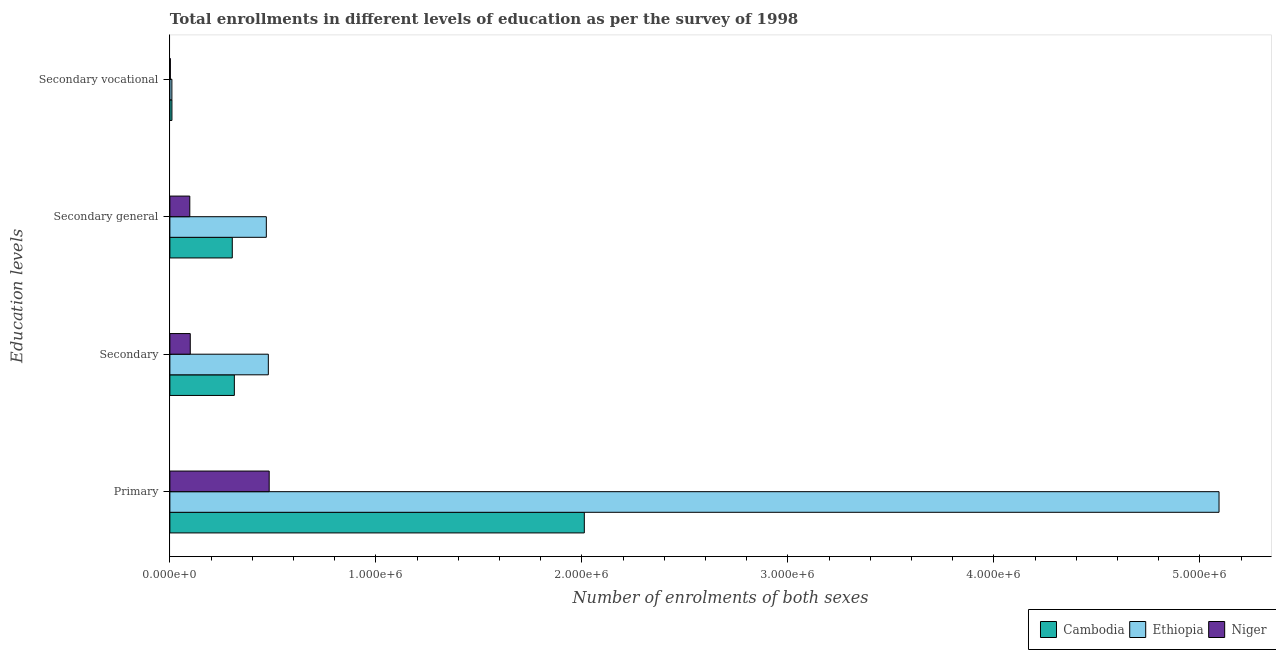How many different coloured bars are there?
Your answer should be very brief. 3. How many bars are there on the 3rd tick from the bottom?
Keep it short and to the point. 3. What is the label of the 4th group of bars from the top?
Your answer should be compact. Primary. What is the number of enrolments in secondary education in Cambodia?
Give a very brief answer. 3.13e+05. Across all countries, what is the maximum number of enrolments in primary education?
Offer a very short reply. 5.09e+06. Across all countries, what is the minimum number of enrolments in secondary general education?
Ensure brevity in your answer.  9.67e+04. In which country was the number of enrolments in secondary general education maximum?
Your answer should be very brief. Ethiopia. In which country was the number of enrolments in secondary general education minimum?
Give a very brief answer. Niger. What is the total number of enrolments in secondary education in the graph?
Your answer should be compact. 8.90e+05. What is the difference between the number of enrolments in secondary general education in Niger and that in Cambodia?
Offer a very short reply. -2.06e+05. What is the difference between the number of enrolments in secondary vocational education in Niger and the number of enrolments in primary education in Cambodia?
Your answer should be very brief. -2.01e+06. What is the average number of enrolments in secondary education per country?
Ensure brevity in your answer.  2.97e+05. What is the difference between the number of enrolments in secondary general education and number of enrolments in secondary vocational education in Cambodia?
Offer a very short reply. 2.93e+05. What is the ratio of the number of enrolments in secondary vocational education in Ethiopia to that in Niger?
Provide a succinct answer. 4.33. Is the number of enrolments in primary education in Cambodia less than that in Niger?
Give a very brief answer. No. What is the difference between the highest and the second highest number of enrolments in secondary education?
Provide a short and direct response. 1.65e+05. What is the difference between the highest and the lowest number of enrolments in secondary vocational education?
Provide a short and direct response. 7729. What does the 1st bar from the top in Secondary vocational represents?
Your answer should be compact. Niger. What does the 3rd bar from the bottom in Secondary represents?
Provide a succinct answer. Niger. Is it the case that in every country, the sum of the number of enrolments in primary education and number of enrolments in secondary education is greater than the number of enrolments in secondary general education?
Provide a short and direct response. Yes. How many bars are there?
Keep it short and to the point. 12. Are all the bars in the graph horizontal?
Provide a short and direct response. Yes. Does the graph contain any zero values?
Offer a terse response. No. Does the graph contain grids?
Keep it short and to the point. No. Where does the legend appear in the graph?
Your answer should be compact. Bottom right. What is the title of the graph?
Provide a short and direct response. Total enrollments in different levels of education as per the survey of 1998. What is the label or title of the X-axis?
Keep it short and to the point. Number of enrolments of both sexes. What is the label or title of the Y-axis?
Provide a short and direct response. Education levels. What is the Number of enrolments of both sexes in Cambodia in Primary?
Offer a very short reply. 2.01e+06. What is the Number of enrolments of both sexes of Ethiopia in Primary?
Offer a very short reply. 5.09e+06. What is the Number of enrolments of both sexes of Niger in Primary?
Ensure brevity in your answer.  4.82e+05. What is the Number of enrolments of both sexes of Cambodia in Secondary?
Make the answer very short. 3.13e+05. What is the Number of enrolments of both sexes of Ethiopia in Secondary?
Your answer should be very brief. 4.78e+05. What is the Number of enrolments of both sexes in Niger in Secondary?
Give a very brief answer. 9.90e+04. What is the Number of enrolments of both sexes of Cambodia in Secondary general?
Keep it short and to the point. 3.03e+05. What is the Number of enrolments of both sexes in Ethiopia in Secondary general?
Provide a succinct answer. 4.68e+05. What is the Number of enrolments of both sexes of Niger in Secondary general?
Your answer should be very brief. 9.67e+04. What is the Number of enrolments of both sexes of Cambodia in Secondary vocational?
Provide a succinct answer. 9983. What is the Number of enrolments of both sexes of Ethiopia in Secondary vocational?
Your answer should be compact. 9771. What is the Number of enrolments of both sexes in Niger in Secondary vocational?
Offer a very short reply. 2254. Across all Education levels, what is the maximum Number of enrolments of both sexes in Cambodia?
Offer a terse response. 2.01e+06. Across all Education levels, what is the maximum Number of enrolments of both sexes in Ethiopia?
Keep it short and to the point. 5.09e+06. Across all Education levels, what is the maximum Number of enrolments of both sexes of Niger?
Provide a short and direct response. 4.82e+05. Across all Education levels, what is the minimum Number of enrolments of both sexes in Cambodia?
Provide a short and direct response. 9983. Across all Education levels, what is the minimum Number of enrolments of both sexes in Ethiopia?
Keep it short and to the point. 9771. Across all Education levels, what is the minimum Number of enrolments of both sexes in Niger?
Your answer should be very brief. 2254. What is the total Number of enrolments of both sexes in Cambodia in the graph?
Give a very brief answer. 2.64e+06. What is the total Number of enrolments of both sexes in Ethiopia in the graph?
Provide a short and direct response. 6.05e+06. What is the total Number of enrolments of both sexes of Niger in the graph?
Make the answer very short. 6.80e+05. What is the difference between the Number of enrolments of both sexes in Cambodia in Primary and that in Secondary?
Keep it short and to the point. 1.70e+06. What is the difference between the Number of enrolments of both sexes of Ethiopia in Primary and that in Secondary?
Provide a succinct answer. 4.61e+06. What is the difference between the Number of enrolments of both sexes in Niger in Primary and that in Secondary?
Offer a very short reply. 3.83e+05. What is the difference between the Number of enrolments of both sexes of Cambodia in Primary and that in Secondary general?
Your response must be concise. 1.71e+06. What is the difference between the Number of enrolments of both sexes in Ethiopia in Primary and that in Secondary general?
Your response must be concise. 4.62e+06. What is the difference between the Number of enrolments of both sexes in Niger in Primary and that in Secondary general?
Your answer should be compact. 3.85e+05. What is the difference between the Number of enrolments of both sexes in Cambodia in Primary and that in Secondary vocational?
Your response must be concise. 2.00e+06. What is the difference between the Number of enrolments of both sexes in Ethiopia in Primary and that in Secondary vocational?
Your answer should be very brief. 5.08e+06. What is the difference between the Number of enrolments of both sexes in Niger in Primary and that in Secondary vocational?
Keep it short and to the point. 4.80e+05. What is the difference between the Number of enrolments of both sexes of Cambodia in Secondary and that in Secondary general?
Give a very brief answer. 9983. What is the difference between the Number of enrolments of both sexes of Ethiopia in Secondary and that in Secondary general?
Ensure brevity in your answer.  9771. What is the difference between the Number of enrolments of both sexes of Niger in Secondary and that in Secondary general?
Offer a terse response. 2254. What is the difference between the Number of enrolments of both sexes in Cambodia in Secondary and that in Secondary vocational?
Keep it short and to the point. 3.03e+05. What is the difference between the Number of enrolments of both sexes in Ethiopia in Secondary and that in Secondary vocational?
Offer a terse response. 4.68e+05. What is the difference between the Number of enrolments of both sexes of Niger in Secondary and that in Secondary vocational?
Make the answer very short. 9.67e+04. What is the difference between the Number of enrolments of both sexes in Cambodia in Secondary general and that in Secondary vocational?
Your response must be concise. 2.93e+05. What is the difference between the Number of enrolments of both sexes of Ethiopia in Secondary general and that in Secondary vocational?
Keep it short and to the point. 4.58e+05. What is the difference between the Number of enrolments of both sexes in Niger in Secondary general and that in Secondary vocational?
Offer a very short reply. 9.45e+04. What is the difference between the Number of enrolments of both sexes in Cambodia in Primary and the Number of enrolments of both sexes in Ethiopia in Secondary?
Provide a succinct answer. 1.53e+06. What is the difference between the Number of enrolments of both sexes in Cambodia in Primary and the Number of enrolments of both sexes in Niger in Secondary?
Offer a terse response. 1.91e+06. What is the difference between the Number of enrolments of both sexes of Ethiopia in Primary and the Number of enrolments of both sexes of Niger in Secondary?
Offer a terse response. 4.99e+06. What is the difference between the Number of enrolments of both sexes in Cambodia in Primary and the Number of enrolments of both sexes in Ethiopia in Secondary general?
Offer a terse response. 1.54e+06. What is the difference between the Number of enrolments of both sexes of Cambodia in Primary and the Number of enrolments of both sexes of Niger in Secondary general?
Keep it short and to the point. 1.92e+06. What is the difference between the Number of enrolments of both sexes in Ethiopia in Primary and the Number of enrolments of both sexes in Niger in Secondary general?
Provide a short and direct response. 5.00e+06. What is the difference between the Number of enrolments of both sexes of Cambodia in Primary and the Number of enrolments of both sexes of Ethiopia in Secondary vocational?
Your answer should be very brief. 2.00e+06. What is the difference between the Number of enrolments of both sexes in Cambodia in Primary and the Number of enrolments of both sexes in Niger in Secondary vocational?
Your answer should be very brief. 2.01e+06. What is the difference between the Number of enrolments of both sexes of Ethiopia in Primary and the Number of enrolments of both sexes of Niger in Secondary vocational?
Keep it short and to the point. 5.09e+06. What is the difference between the Number of enrolments of both sexes in Cambodia in Secondary and the Number of enrolments of both sexes in Ethiopia in Secondary general?
Offer a very short reply. -1.55e+05. What is the difference between the Number of enrolments of both sexes in Cambodia in Secondary and the Number of enrolments of both sexes in Niger in Secondary general?
Your response must be concise. 2.16e+05. What is the difference between the Number of enrolments of both sexes of Ethiopia in Secondary and the Number of enrolments of both sexes of Niger in Secondary general?
Make the answer very short. 3.81e+05. What is the difference between the Number of enrolments of both sexes of Cambodia in Secondary and the Number of enrolments of both sexes of Ethiopia in Secondary vocational?
Your answer should be very brief. 3.03e+05. What is the difference between the Number of enrolments of both sexes in Cambodia in Secondary and the Number of enrolments of both sexes in Niger in Secondary vocational?
Keep it short and to the point. 3.11e+05. What is the difference between the Number of enrolments of both sexes in Ethiopia in Secondary and the Number of enrolments of both sexes in Niger in Secondary vocational?
Provide a short and direct response. 4.76e+05. What is the difference between the Number of enrolments of both sexes of Cambodia in Secondary general and the Number of enrolments of both sexes of Ethiopia in Secondary vocational?
Provide a short and direct response. 2.93e+05. What is the difference between the Number of enrolments of both sexes in Cambodia in Secondary general and the Number of enrolments of both sexes in Niger in Secondary vocational?
Your answer should be very brief. 3.01e+05. What is the difference between the Number of enrolments of both sexes of Ethiopia in Secondary general and the Number of enrolments of both sexes of Niger in Secondary vocational?
Give a very brief answer. 4.66e+05. What is the average Number of enrolments of both sexes in Cambodia per Education levels?
Your answer should be very brief. 6.59e+05. What is the average Number of enrolments of both sexes in Ethiopia per Education levels?
Give a very brief answer. 1.51e+06. What is the average Number of enrolments of both sexes in Niger per Education levels?
Make the answer very short. 1.70e+05. What is the difference between the Number of enrolments of both sexes of Cambodia and Number of enrolments of both sexes of Ethiopia in Primary?
Your answer should be very brief. -3.08e+06. What is the difference between the Number of enrolments of both sexes in Cambodia and Number of enrolments of both sexes in Niger in Primary?
Provide a succinct answer. 1.53e+06. What is the difference between the Number of enrolments of both sexes in Ethiopia and Number of enrolments of both sexes in Niger in Primary?
Give a very brief answer. 4.61e+06. What is the difference between the Number of enrolments of both sexes of Cambodia and Number of enrolments of both sexes of Ethiopia in Secondary?
Provide a short and direct response. -1.65e+05. What is the difference between the Number of enrolments of both sexes in Cambodia and Number of enrolments of both sexes in Niger in Secondary?
Offer a terse response. 2.14e+05. What is the difference between the Number of enrolments of both sexes of Ethiopia and Number of enrolments of both sexes of Niger in Secondary?
Your answer should be very brief. 3.79e+05. What is the difference between the Number of enrolments of both sexes of Cambodia and Number of enrolments of both sexes of Ethiopia in Secondary general?
Keep it short and to the point. -1.65e+05. What is the difference between the Number of enrolments of both sexes of Cambodia and Number of enrolments of both sexes of Niger in Secondary general?
Make the answer very short. 2.06e+05. What is the difference between the Number of enrolments of both sexes in Ethiopia and Number of enrolments of both sexes in Niger in Secondary general?
Offer a terse response. 3.71e+05. What is the difference between the Number of enrolments of both sexes of Cambodia and Number of enrolments of both sexes of Ethiopia in Secondary vocational?
Provide a short and direct response. 212. What is the difference between the Number of enrolments of both sexes in Cambodia and Number of enrolments of both sexes in Niger in Secondary vocational?
Ensure brevity in your answer.  7729. What is the difference between the Number of enrolments of both sexes in Ethiopia and Number of enrolments of both sexes in Niger in Secondary vocational?
Your answer should be compact. 7517. What is the ratio of the Number of enrolments of both sexes of Cambodia in Primary to that in Secondary?
Make the answer very short. 6.43. What is the ratio of the Number of enrolments of both sexes of Ethiopia in Primary to that in Secondary?
Provide a succinct answer. 10.66. What is the ratio of the Number of enrolments of both sexes of Niger in Primary to that in Secondary?
Your answer should be very brief. 4.87. What is the ratio of the Number of enrolments of both sexes in Cambodia in Primary to that in Secondary general?
Your response must be concise. 6.64. What is the ratio of the Number of enrolments of both sexes of Ethiopia in Primary to that in Secondary general?
Your answer should be very brief. 10.88. What is the ratio of the Number of enrolments of both sexes of Niger in Primary to that in Secondary general?
Give a very brief answer. 4.98. What is the ratio of the Number of enrolments of both sexes in Cambodia in Primary to that in Secondary vocational?
Provide a short and direct response. 201.52. What is the ratio of the Number of enrolments of both sexes of Ethiopia in Primary to that in Secondary vocational?
Make the answer very short. 521.21. What is the ratio of the Number of enrolments of both sexes of Niger in Primary to that in Secondary vocational?
Your response must be concise. 213.87. What is the ratio of the Number of enrolments of both sexes of Cambodia in Secondary to that in Secondary general?
Ensure brevity in your answer.  1.03. What is the ratio of the Number of enrolments of both sexes of Ethiopia in Secondary to that in Secondary general?
Provide a short and direct response. 1.02. What is the ratio of the Number of enrolments of both sexes of Niger in Secondary to that in Secondary general?
Provide a short and direct response. 1.02. What is the ratio of the Number of enrolments of both sexes of Cambodia in Secondary to that in Secondary vocational?
Offer a very short reply. 31.35. What is the ratio of the Number of enrolments of both sexes in Ethiopia in Secondary to that in Secondary vocational?
Give a very brief answer. 48.91. What is the ratio of the Number of enrolments of both sexes in Niger in Secondary to that in Secondary vocational?
Make the answer very short. 43.91. What is the ratio of the Number of enrolments of both sexes of Cambodia in Secondary general to that in Secondary vocational?
Provide a succinct answer. 30.35. What is the ratio of the Number of enrolments of both sexes in Ethiopia in Secondary general to that in Secondary vocational?
Your answer should be compact. 47.91. What is the ratio of the Number of enrolments of both sexes in Niger in Secondary general to that in Secondary vocational?
Keep it short and to the point. 42.91. What is the difference between the highest and the second highest Number of enrolments of both sexes in Cambodia?
Offer a terse response. 1.70e+06. What is the difference between the highest and the second highest Number of enrolments of both sexes in Ethiopia?
Offer a very short reply. 4.61e+06. What is the difference between the highest and the second highest Number of enrolments of both sexes in Niger?
Your response must be concise. 3.83e+05. What is the difference between the highest and the lowest Number of enrolments of both sexes of Cambodia?
Your response must be concise. 2.00e+06. What is the difference between the highest and the lowest Number of enrolments of both sexes of Ethiopia?
Offer a very short reply. 5.08e+06. What is the difference between the highest and the lowest Number of enrolments of both sexes in Niger?
Give a very brief answer. 4.80e+05. 